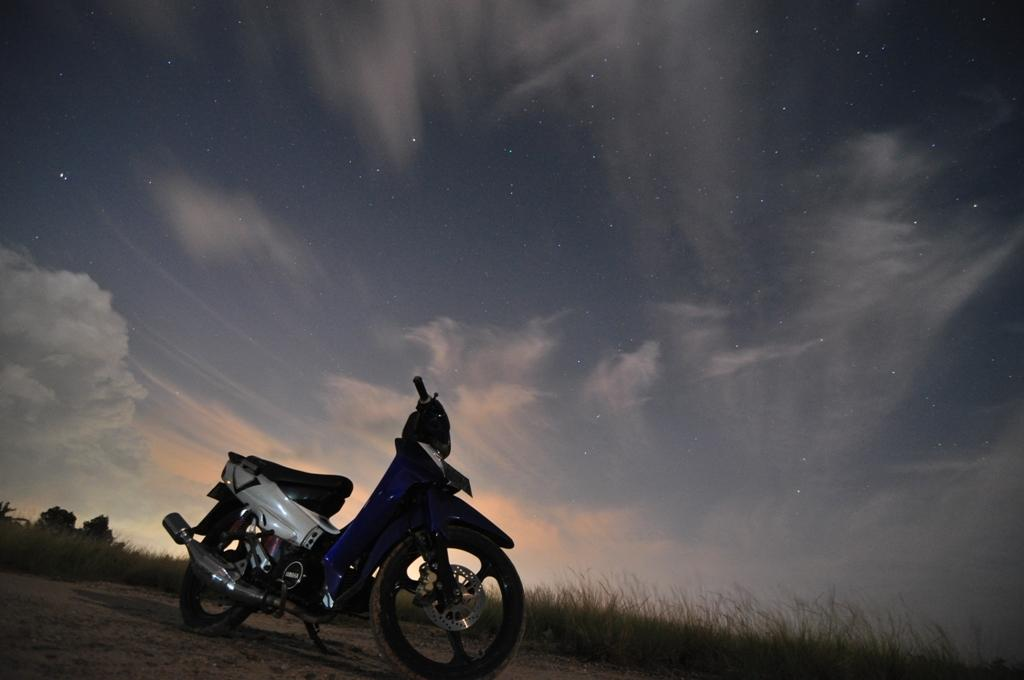What is the main object in the image? There is a scooter in the image. What can be seen in the background of the image? There is grass, the sky, clouds, and trees in the background of the image. Can you describe the sky in the image? The sky is visible in the background of the image, and there are clouds present. How many legs does the scooter have in the image? Scooters do not have legs; they have wheels. In this image, the scooter has two wheels. 